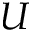<formula> <loc_0><loc_0><loc_500><loc_500>U</formula> 